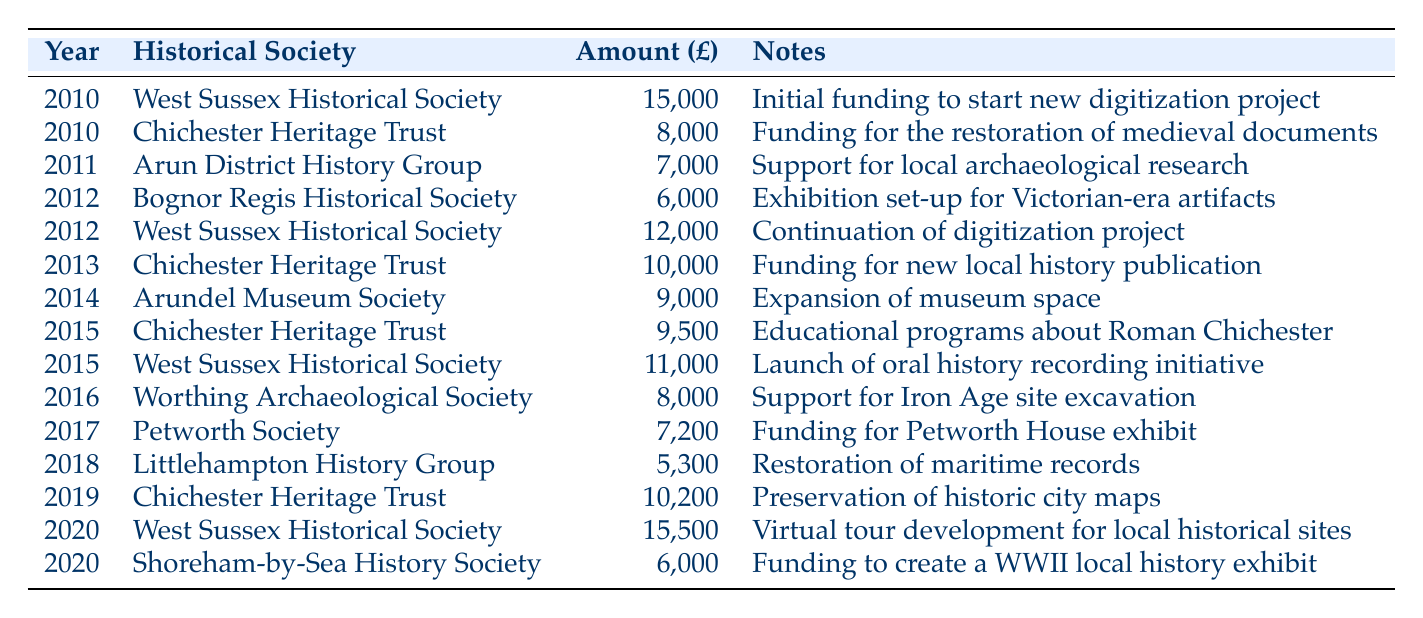What was the highest amount distributed in a single year? The highest amount in the table is found in the year 2020 with the distribution of £15,500 to West Sussex Historical Society.
Answer: £15,500 How much did Chichester Heritage Trust receive in total from 2010 to 2020? Chichester Heritage Trust received £8,000 in 2010, £10,000 in 2013, £9,500 in 2015, and £10,200 in 2019. Adding these amounts gives £8,000 + £10,000 + £9,500 + £10,200 = £37,700.
Answer: £37,700 Did the West Sussex Historical Society receive funding for a digitization project? Yes, they received funding in 2010 for the initial funding of a new digitization project and continued funding in 2012 for the same project.
Answer: Yes Which historical society received the lowest amount and in what year? The lowest amount in the table is £5,300 given to Littlehampton History Group in the year 2018.
Answer: £5,300 in 2018 What was the total amount distributed in 2015? For 2015, the amounts distributed are £9,500 to Chichester Heritage Trust and £11,000 to West Sussex Historical Society. The total is £9,500 + £11,000 = £20,500.
Answer: £20,500 How many different historical societies received funding in 2012? In 2012, there were two different historical societies that received funding: Bognor Regis Historical Society and West Sussex Historical Society.
Answer: 2 Was there any funding for exhibitions in 2017? No, there is no mention of any funding for exhibitions in 2017 in the table. Instead, funding was for a Petworth House exhibit.
Answer: No How much has been allocated to archaeological projects from 2010 to 2020? The only entries related to archaeological projects are £7,000 in 2011 for Arun District History Group and £8,000 in 2016 for Worthing Archaeological Society. The total here is £7,000 + £8,000 = £15,000.
Answer: £15,000 Which year saw the greatest overall funding distribution? The greatest overall funding can be calculated by summing all distributions for each year. For 2020, the total is £15,500 + £6,000 = £21,500, which exceeds other years.
Answer: 2020 